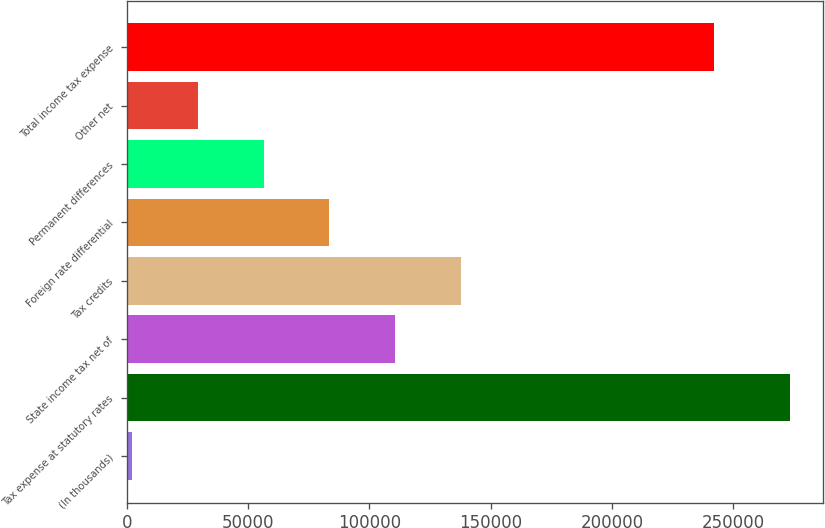Convert chart. <chart><loc_0><loc_0><loc_500><loc_500><bar_chart><fcel>(In thousands)<fcel>Tax expense at statutory rates<fcel>State income tax net of<fcel>Tax credits<fcel>Foreign rate differential<fcel>Permanent differences<fcel>Other net<fcel>Total income tax expense<nl><fcel>2015<fcel>273483<fcel>110602<fcel>137749<fcel>83455.4<fcel>56308.6<fcel>29161.8<fcel>242018<nl></chart> 